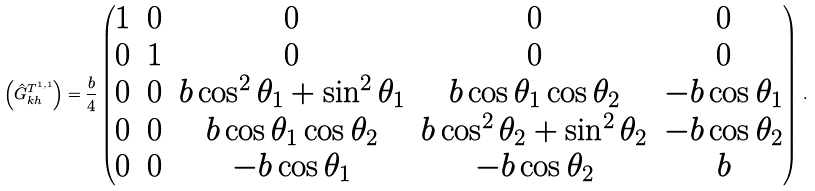Convert formula to latex. <formula><loc_0><loc_0><loc_500><loc_500>\left ( \hat { G } _ { k h } ^ { T ^ { 1 , 1 } } \right ) = \frac { b } { 4 } \left ( \begin{matrix} 1 & 0 & 0 & 0 & 0 \\ 0 & 1 & 0 & 0 & 0 \\ 0 & 0 & b \cos ^ { 2 } \theta _ { 1 } + \sin ^ { 2 } \theta _ { 1 } & b \cos \theta _ { 1 } \cos \theta _ { 2 } & - b \cos \theta _ { 1 } \\ 0 & 0 & b \cos \theta _ { 1 } \cos \theta _ { 2 } & b \cos ^ { 2 } \theta _ { 2 } + \sin ^ { 2 } \theta _ { 2 } & - b \cos \theta _ { 2 } \\ 0 & 0 & - b \cos \theta _ { 1 } & - b \cos \theta _ { 2 } & b \end{matrix} \right ) \, .</formula> 